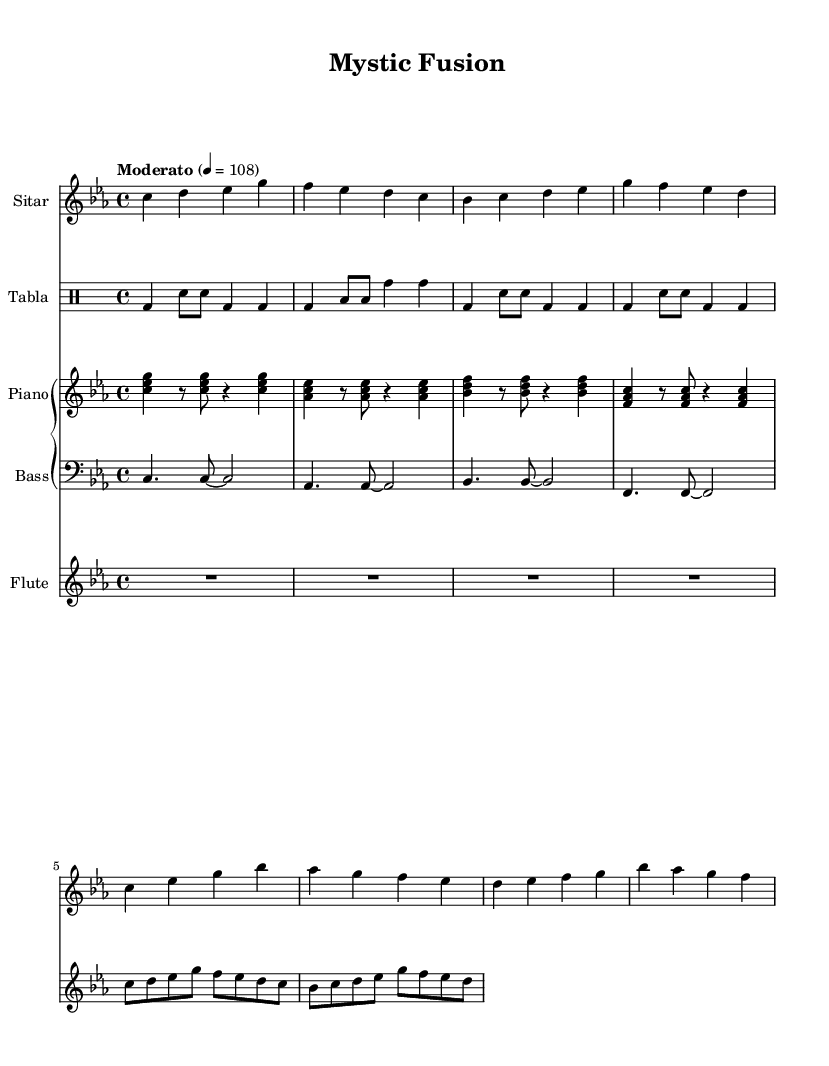What is the key signature of this music? The key signature indicated in the sheet music is C minor, as it shows three flats (B♭, E♭, and A♭).
Answer: C minor What is the time signature of the piece? The time signature in the sheet music is 4/4, which means there are four beats in each measure.
Answer: 4/4 What is the tempo marking for this piece? The tempo marking shown is "Moderato," with a metronome marking of 108, indicating a moderate pace.
Answer: Moderato 4 = 108 How many different instruments are featured in the score? The score includes four different instruments: sitar, tabla, piano (including bass), and flute. By counting the unique instrumental staves, we see there are four.
Answer: Four What kind of rhythmic patterns are used in the tabla section? The tabla section features a mix of bass drum (bd) and various snare (sn) and tom (toml, tomh) patterns, creating a rich percussive texture typical of Indo-jazz fusion.
Answer: Mixed patterns Which instrument plays the highest pitch throughout the piece? The flute is typically the highest instrument among the featured staves, producing notes such as high C and D. Looking at the respective lines in the staff, the flute reaches pitches that are higher than all others.
Answer: Flute What is the primary harmonic function of the piano in this composition? The piano plays chords that establish harmonic support for the melody, moving between C minor-related triads which creates tonal stability underlying the improvisational aspects of the other instruments.
Answer: Harmonic support 